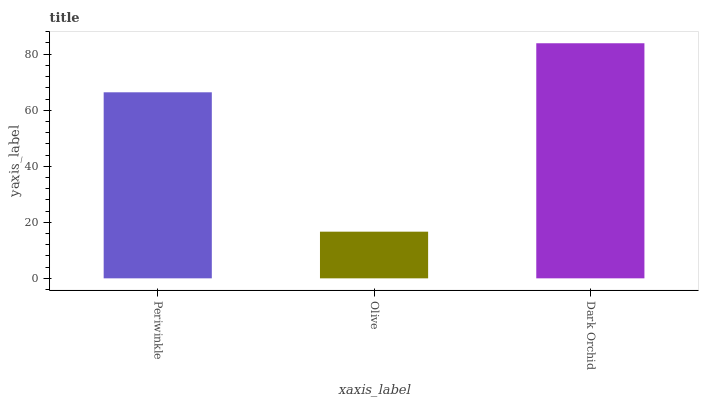Is Dark Orchid the minimum?
Answer yes or no. No. Is Olive the maximum?
Answer yes or no. No. Is Dark Orchid greater than Olive?
Answer yes or no. Yes. Is Olive less than Dark Orchid?
Answer yes or no. Yes. Is Olive greater than Dark Orchid?
Answer yes or no. No. Is Dark Orchid less than Olive?
Answer yes or no. No. Is Periwinkle the high median?
Answer yes or no. Yes. Is Periwinkle the low median?
Answer yes or no. Yes. Is Dark Orchid the high median?
Answer yes or no. No. Is Dark Orchid the low median?
Answer yes or no. No. 